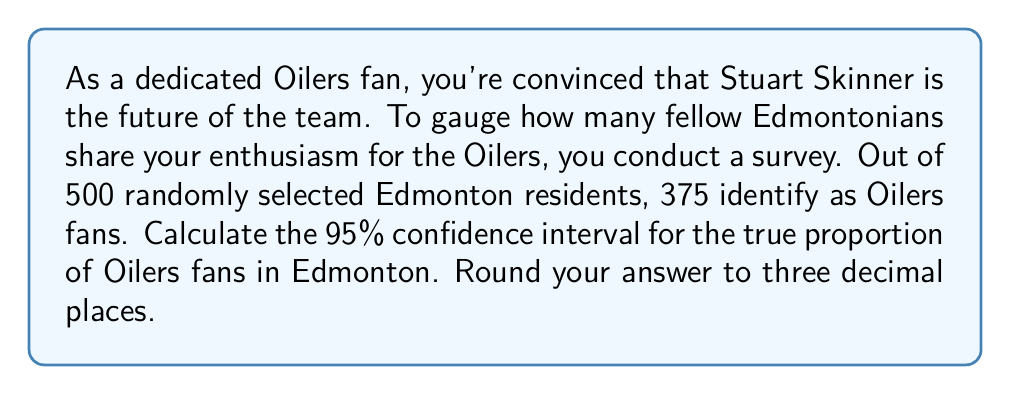Provide a solution to this math problem. Let's approach this step-by-step:

1) First, we need to identify our variables:
   $n$ = sample size = 500
   $\hat{p}$ = sample proportion = 375/500 = 0.75
   Confidence level = 95%, so $z^*$ = 1.96

2) The formula for the confidence interval is:

   $$\hat{p} \pm z^* \sqrt{\frac{\hat{p}(1-\hat{p})}{n}}$$

3) Let's calculate the margin of error:

   $$z^* \sqrt{\frac{\hat{p}(1-\hat{p})}{n}} = 1.96 \sqrt{\frac{0.75(1-0.75)}{500}}$$
   
   $$= 1.96 \sqrt{\frac{0.1875}{500}} = 1.96 \sqrt{0.000375} = 1.96(0.0194) = 0.038$$

4) Now we can calculate the confidence interval:

   Lower bound: $0.75 - 0.038 = 0.712$
   Upper bound: $0.75 + 0.038 = 0.788$

5) Rounding to three decimal places:

   The 95% confidence interval is (0.712, 0.788)

This means we can be 95% confident that the true proportion of Oilers fans in Edmonton is between 71.2% and 78.8%.
Answer: (0.712, 0.788) 